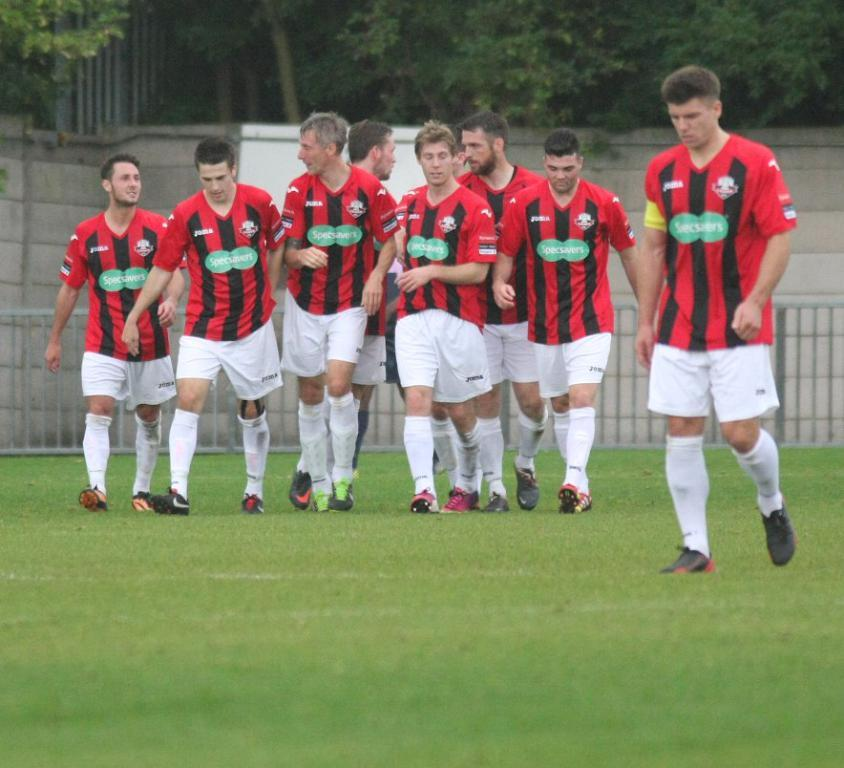What are the men in the image doing? The men in the image are walking. On what surface are the men walking? The men are walking on the grass. What can be seen in the background of the image? There is a wall, a fence, and trees in the background of the image. How many icicles are hanging from the wall in the image? There are no icicles present in the image; it is not snowing or cold enough for icicles to form. 